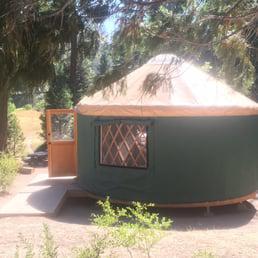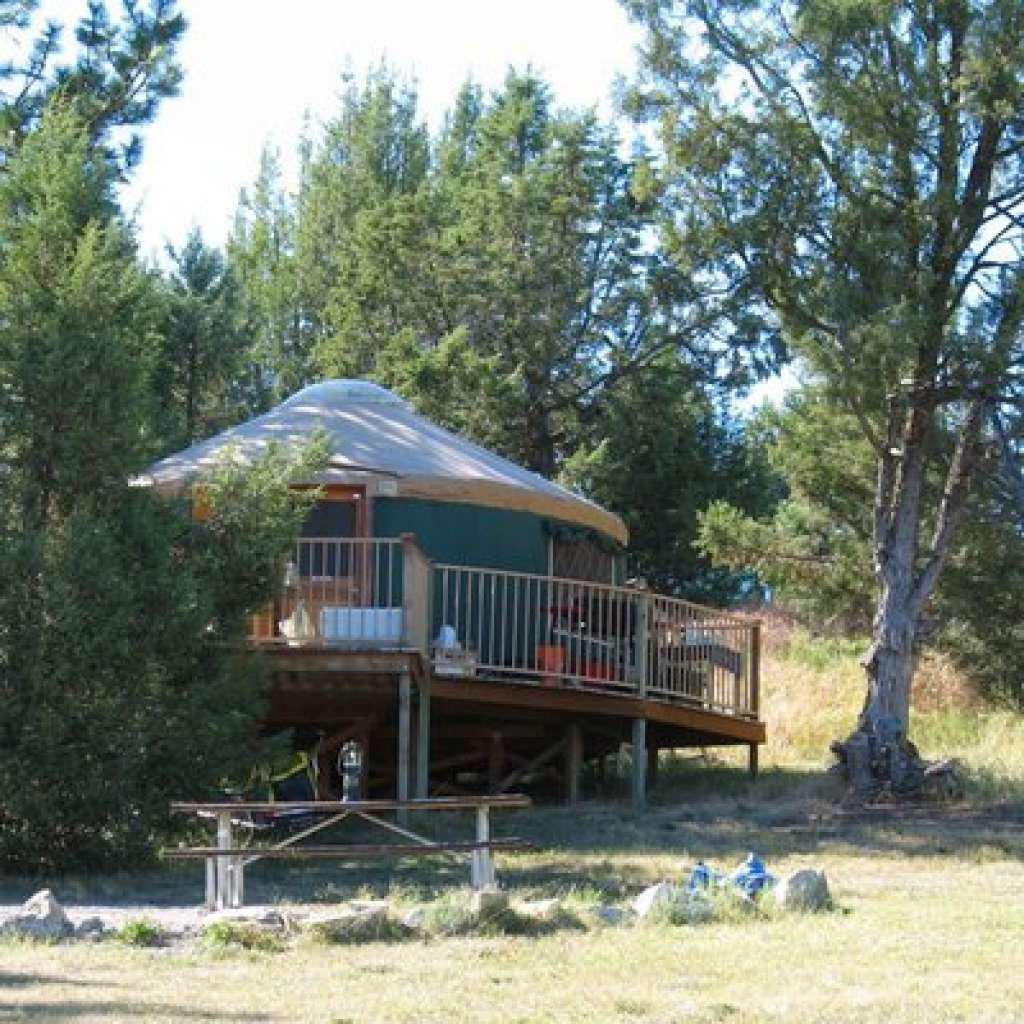The first image is the image on the left, the second image is the image on the right. Evaluate the accuracy of this statement regarding the images: "One of the images is of the outside of a yurt, and the other is of the inside, and there is no snow visible in either of them.". Is it true? Answer yes or no. No. The first image is the image on the left, the second image is the image on the right. Analyze the images presented: Is the assertion "There are at least five items hanging in a line on the back wall." valid? Answer yes or no. No. 